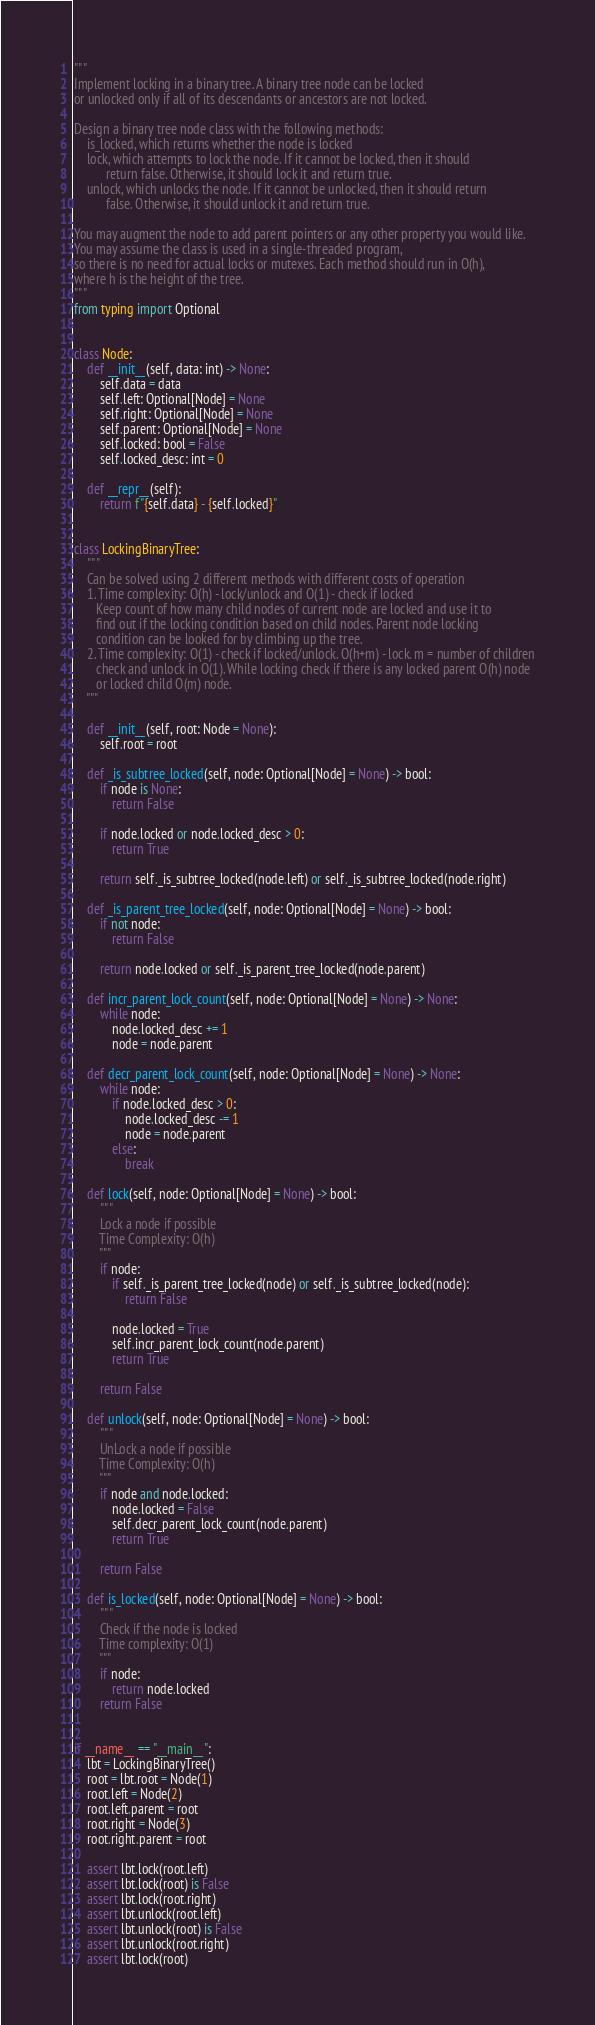Convert code to text. <code><loc_0><loc_0><loc_500><loc_500><_Python_>"""
Implement locking in a binary tree. A binary tree node can be locked
or unlocked only if all of its descendants or ancestors are not locked.

Design a binary tree node class with the following methods:
    is_locked, which returns whether the node is locked
    lock, which attempts to lock the node. If it cannot be locked, then it should
          return false. Otherwise, it should lock it and return true.
    unlock, which unlocks the node. If it cannot be unlocked, then it should return
          false. Otherwise, it should unlock it and return true.

You may augment the node to add parent pointers or any other property you would like.
You may assume the class is used in a single-threaded program,
so there is no need for actual locks or mutexes. Each method should run in O(h),
where h is the height of the tree.
"""
from typing import Optional


class Node:
    def __init__(self, data: int) -> None:
        self.data = data
        self.left: Optional[Node] = None
        self.right: Optional[Node] = None
        self.parent: Optional[Node] = None
        self.locked: bool = False
        self.locked_desc: int = 0

    def __repr__(self):
        return f"{self.data} - {self.locked}"


class LockingBinaryTree:
    """
    Can be solved using 2 different methods with different costs of operation
    1. Time complexity: O(h) - lock/unlock and O(1) - check if locked
       Keep count of how many child nodes of current node are locked and use it to
       find out if the locking condition based on child nodes. Parent node locking
       condition can be looked for by climbing up the tree.
    2. Time complexity: O(1) - check if locked/unlock. O(h+m) - lock. m = number of children
       check and unlock in O(1). While locking check if there is any locked parent O(h) node
       or locked child O(m) node.
    """

    def __init__(self, root: Node = None):
        self.root = root

    def _is_subtree_locked(self, node: Optional[Node] = None) -> bool:
        if node is None:
            return False

        if node.locked or node.locked_desc > 0:
            return True

        return self._is_subtree_locked(node.left) or self._is_subtree_locked(node.right)

    def _is_parent_tree_locked(self, node: Optional[Node] = None) -> bool:
        if not node:
            return False

        return node.locked or self._is_parent_tree_locked(node.parent)

    def incr_parent_lock_count(self, node: Optional[Node] = None) -> None:
        while node:
            node.locked_desc += 1
            node = node.parent

    def decr_parent_lock_count(self, node: Optional[Node] = None) -> None:
        while node:
            if node.locked_desc > 0:
                node.locked_desc -= 1
                node = node.parent
            else:
                break

    def lock(self, node: Optional[Node] = None) -> bool:
        """
        Lock a node if possible
        Time Complexity: O(h)
        """
        if node:
            if self._is_parent_tree_locked(node) or self._is_subtree_locked(node):
                return False

            node.locked = True
            self.incr_parent_lock_count(node.parent)
            return True

        return False

    def unlock(self, node: Optional[Node] = None) -> bool:
        """
        UnLock a node if possible
        Time Complexity: O(h)
        """
        if node and node.locked:
            node.locked = False
            self.decr_parent_lock_count(node.parent)
            return True

        return False

    def is_locked(self, node: Optional[Node] = None) -> bool:
        """
        Check if the node is locked
        Time complexity: O(1)
        """
        if node:
            return node.locked
        return False


if __name__ == "__main__":
    lbt = LockingBinaryTree()
    root = lbt.root = Node(1)
    root.left = Node(2)
    root.left.parent = root
    root.right = Node(3)
    root.right.parent = root

    assert lbt.lock(root.left)
    assert lbt.lock(root) is False
    assert lbt.lock(root.right)
    assert lbt.unlock(root.left)
    assert lbt.unlock(root) is False
    assert lbt.unlock(root.right)
    assert lbt.lock(root)</code> 